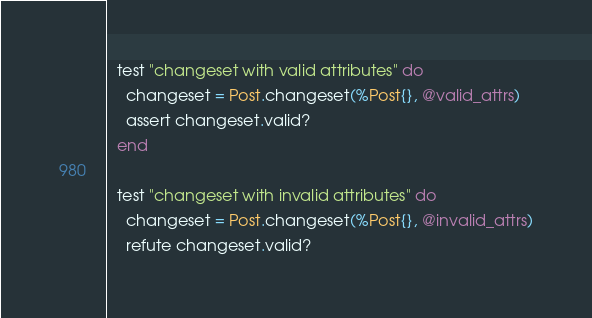<code> <loc_0><loc_0><loc_500><loc_500><_Elixir_>
  test "changeset with valid attributes" do
    changeset = Post.changeset(%Post{}, @valid_attrs)
    assert changeset.valid?
  end

  test "changeset with invalid attributes" do
    changeset = Post.changeset(%Post{}, @invalid_attrs)
    refute changeset.valid?</code> 